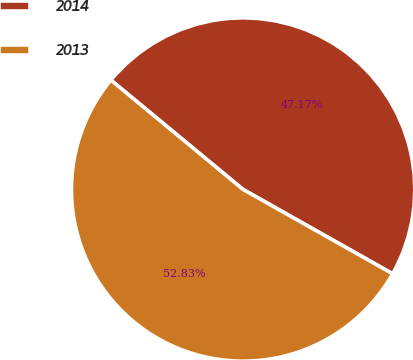<chart> <loc_0><loc_0><loc_500><loc_500><pie_chart><fcel>2014<fcel>2013<nl><fcel>47.17%<fcel>52.83%<nl></chart> 